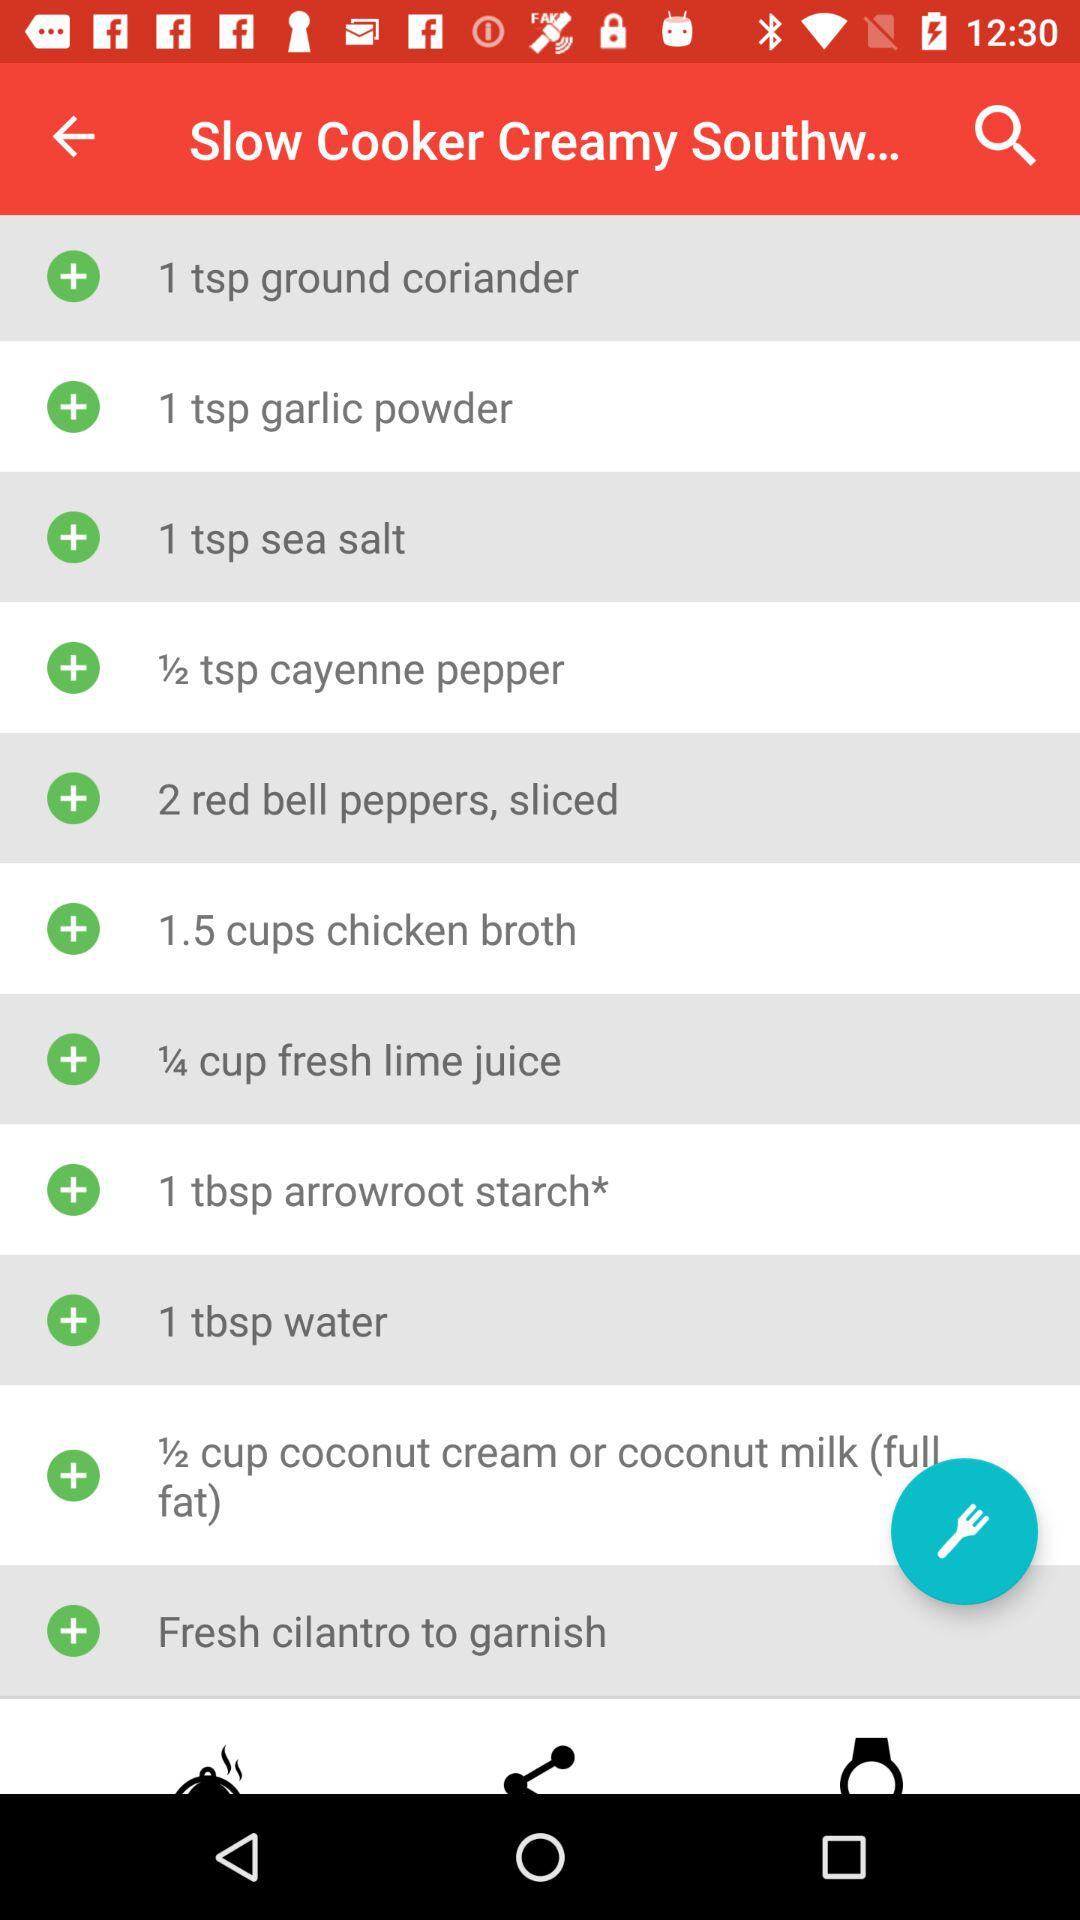What kind of coconut milk is needed? The kind of coconut milk that is needed is full-fat. 